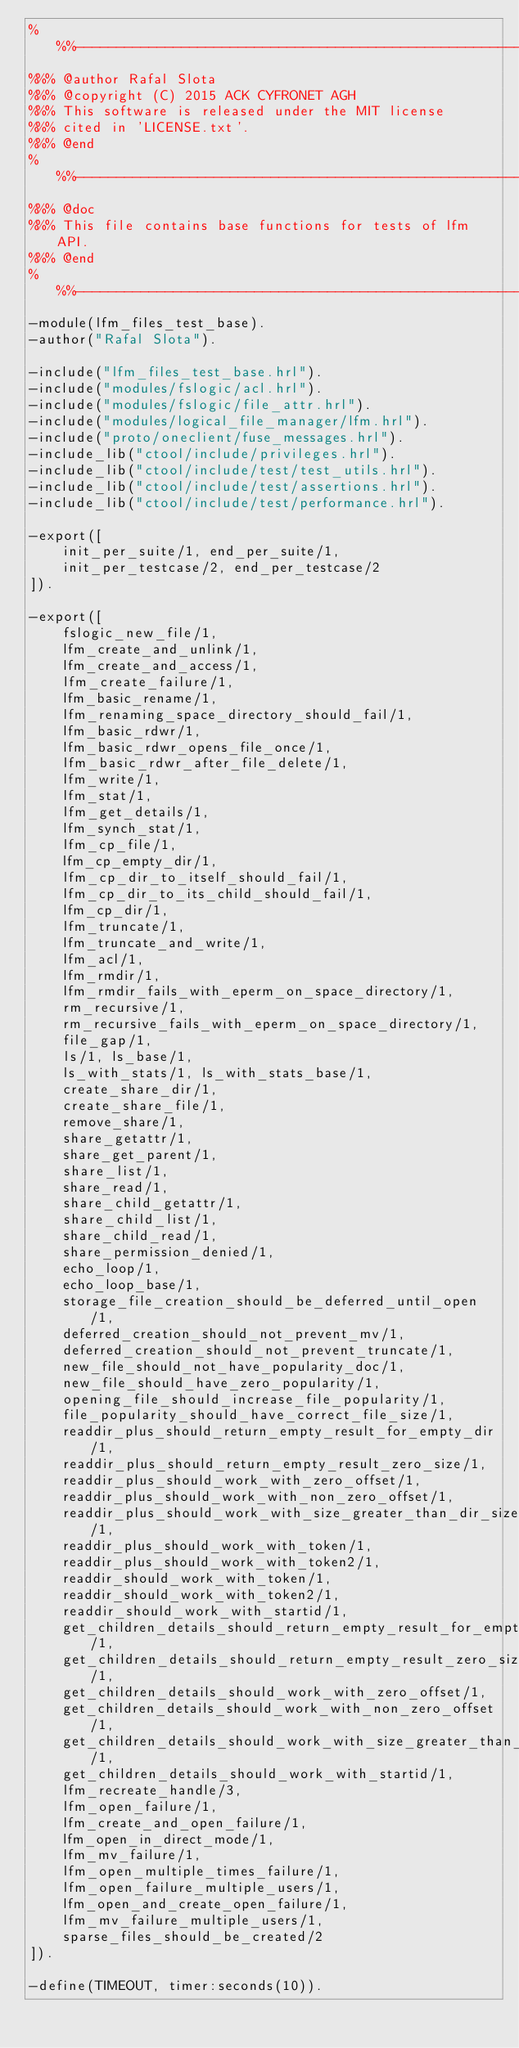<code> <loc_0><loc_0><loc_500><loc_500><_Erlang_>%%%-------------------------------------------------------------------
%%% @author Rafal Slota
%%% @copyright (C) 2015 ACK CYFRONET AGH
%%% This software is released under the MIT license
%%% cited in 'LICENSE.txt'.
%%% @end
%%%-------------------------------------------------------------------
%%% @doc
%%% This file contains base functions for tests of lfm API.
%%% @end
%%%-------------------------------------------------------------------
-module(lfm_files_test_base).
-author("Rafal Slota").

-include("lfm_files_test_base.hrl").
-include("modules/fslogic/acl.hrl").
-include("modules/fslogic/file_attr.hrl").
-include("modules/logical_file_manager/lfm.hrl").
-include("proto/oneclient/fuse_messages.hrl").
-include_lib("ctool/include/privileges.hrl").
-include_lib("ctool/include/test/test_utils.hrl").
-include_lib("ctool/include/test/assertions.hrl").
-include_lib("ctool/include/test/performance.hrl").

-export([
    init_per_suite/1, end_per_suite/1,
    init_per_testcase/2, end_per_testcase/2
]).

-export([
    fslogic_new_file/1,
    lfm_create_and_unlink/1,
    lfm_create_and_access/1,
    lfm_create_failure/1,
    lfm_basic_rename/1,
    lfm_renaming_space_directory_should_fail/1,
    lfm_basic_rdwr/1,
    lfm_basic_rdwr_opens_file_once/1,
    lfm_basic_rdwr_after_file_delete/1,
    lfm_write/1,
    lfm_stat/1,
    lfm_get_details/1,
    lfm_synch_stat/1,
    lfm_cp_file/1,
    lfm_cp_empty_dir/1,
    lfm_cp_dir_to_itself_should_fail/1,
    lfm_cp_dir_to_its_child_should_fail/1,
    lfm_cp_dir/1,
    lfm_truncate/1,
    lfm_truncate_and_write/1,
    lfm_acl/1,
    lfm_rmdir/1,
    lfm_rmdir_fails_with_eperm_on_space_directory/1,
    rm_recursive/1,
    rm_recursive_fails_with_eperm_on_space_directory/1,
    file_gap/1,
    ls/1, ls_base/1,
    ls_with_stats/1, ls_with_stats_base/1,
    create_share_dir/1,
    create_share_file/1,
    remove_share/1,
    share_getattr/1,
    share_get_parent/1,
    share_list/1,
    share_read/1,
    share_child_getattr/1,
    share_child_list/1,
    share_child_read/1,
    share_permission_denied/1,
    echo_loop/1,
    echo_loop_base/1,
    storage_file_creation_should_be_deferred_until_open/1,
    deferred_creation_should_not_prevent_mv/1,
    deferred_creation_should_not_prevent_truncate/1,
    new_file_should_not_have_popularity_doc/1,
    new_file_should_have_zero_popularity/1,
    opening_file_should_increase_file_popularity/1,
    file_popularity_should_have_correct_file_size/1,
    readdir_plus_should_return_empty_result_for_empty_dir/1,
    readdir_plus_should_return_empty_result_zero_size/1,
    readdir_plus_should_work_with_zero_offset/1,
    readdir_plus_should_work_with_non_zero_offset/1,
    readdir_plus_should_work_with_size_greater_than_dir_size/1,
    readdir_plus_should_work_with_token/1,
    readdir_plus_should_work_with_token2/1,
    readdir_should_work_with_token/1,
    readdir_should_work_with_token2/1,
    readdir_should_work_with_startid/1,
    get_children_details_should_return_empty_result_for_empty_dir/1,
    get_children_details_should_return_empty_result_zero_size/1,
    get_children_details_should_work_with_zero_offset/1,
    get_children_details_should_work_with_non_zero_offset/1,
    get_children_details_should_work_with_size_greater_than_dir_size/1,
    get_children_details_should_work_with_startid/1,
    lfm_recreate_handle/3,
    lfm_open_failure/1,
    lfm_create_and_open_failure/1,
    lfm_open_in_direct_mode/1,
    lfm_mv_failure/1,
    lfm_open_multiple_times_failure/1,
    lfm_open_failure_multiple_users/1,
    lfm_open_and_create_open_failure/1,
    lfm_mv_failure_multiple_users/1,
    sparse_files_should_be_created/2
]).

-define(TIMEOUT, timer:seconds(10)).</code> 